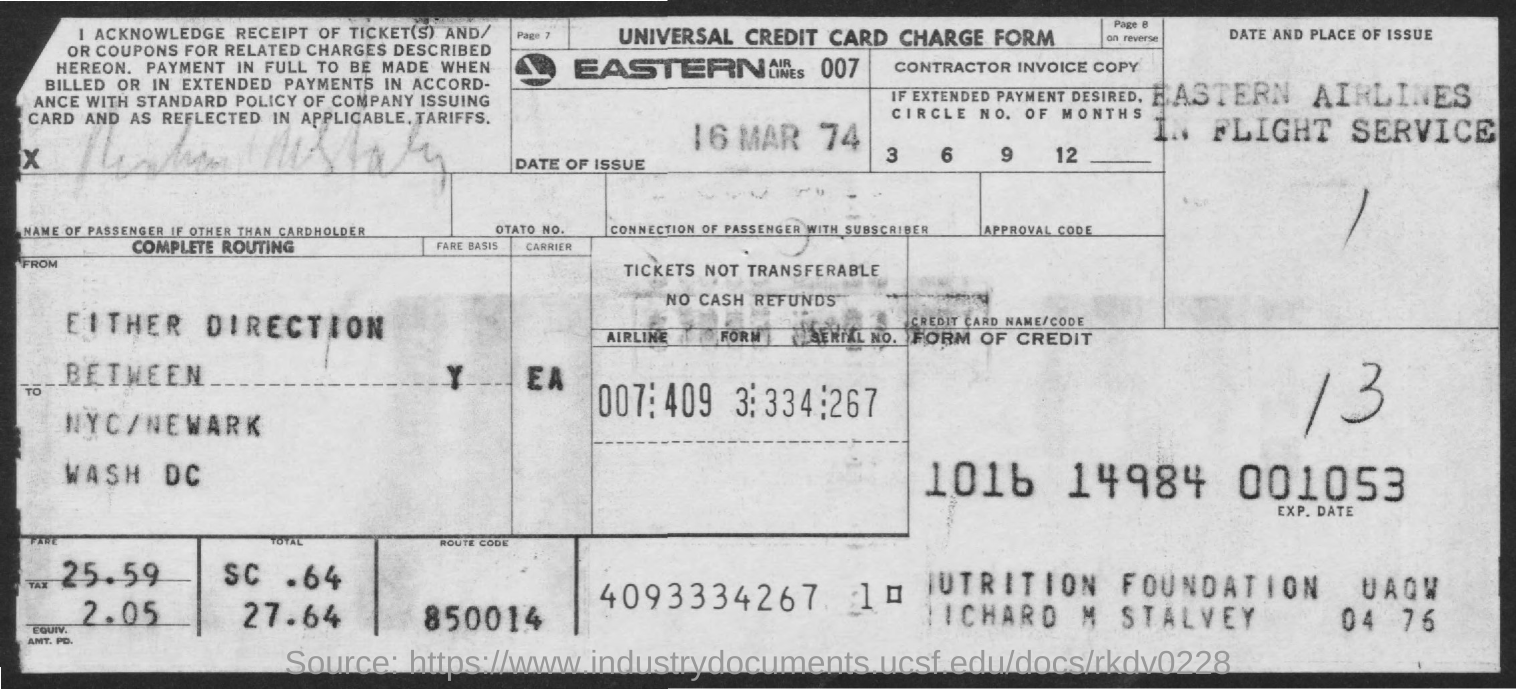What type form is it?
Provide a short and direct response. Universal credit card charge form. What is the date of issue?
Provide a succinct answer. 16 Mar 74. What is the route code?
Offer a terse response. 850014. What is the fare amount?
Keep it short and to the point. 25.59. How much is the tax amount?
Give a very brief answer. 2.05. 